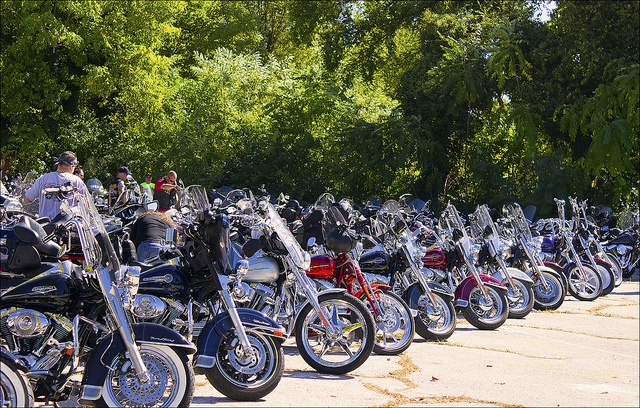Describe the objects in this image and their specific colors. I can see motorcycle in black, gray, and lightgray tones, motorcycle in black, gray, navy, and darkgray tones, motorcycle in black, lightgray, gray, and darkgray tones, motorcycle in black, gray, darkgray, and lightgray tones, and motorcycle in black, gray, darkgray, and lightgray tones in this image. 